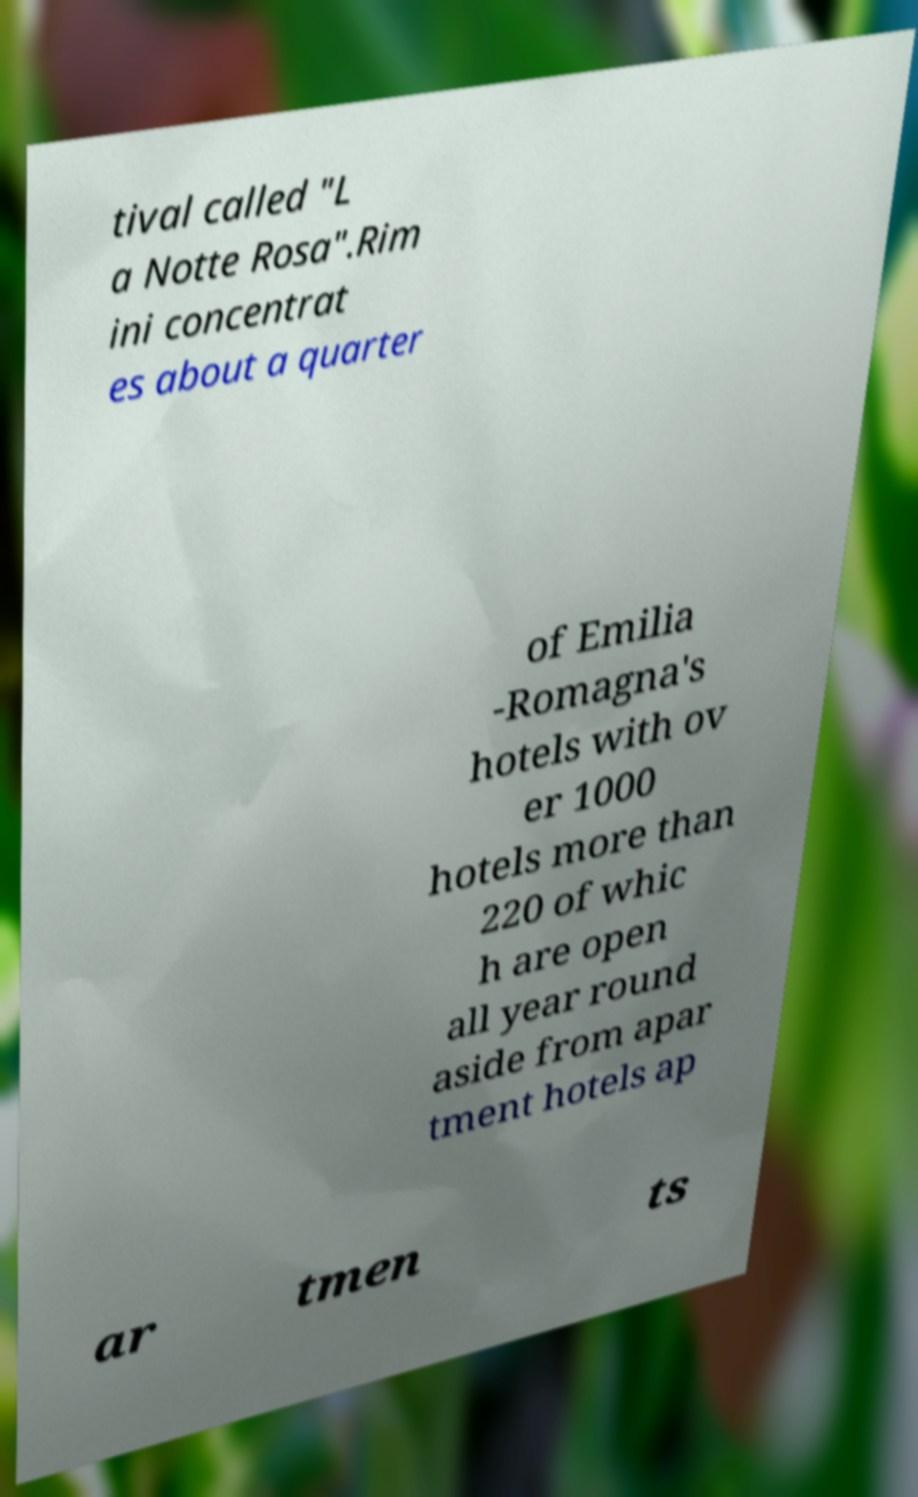For documentation purposes, I need the text within this image transcribed. Could you provide that? tival called "L a Notte Rosa".Rim ini concentrat es about a quarter of Emilia -Romagna's hotels with ov er 1000 hotels more than 220 of whic h are open all year round aside from apar tment hotels ap ar tmen ts 